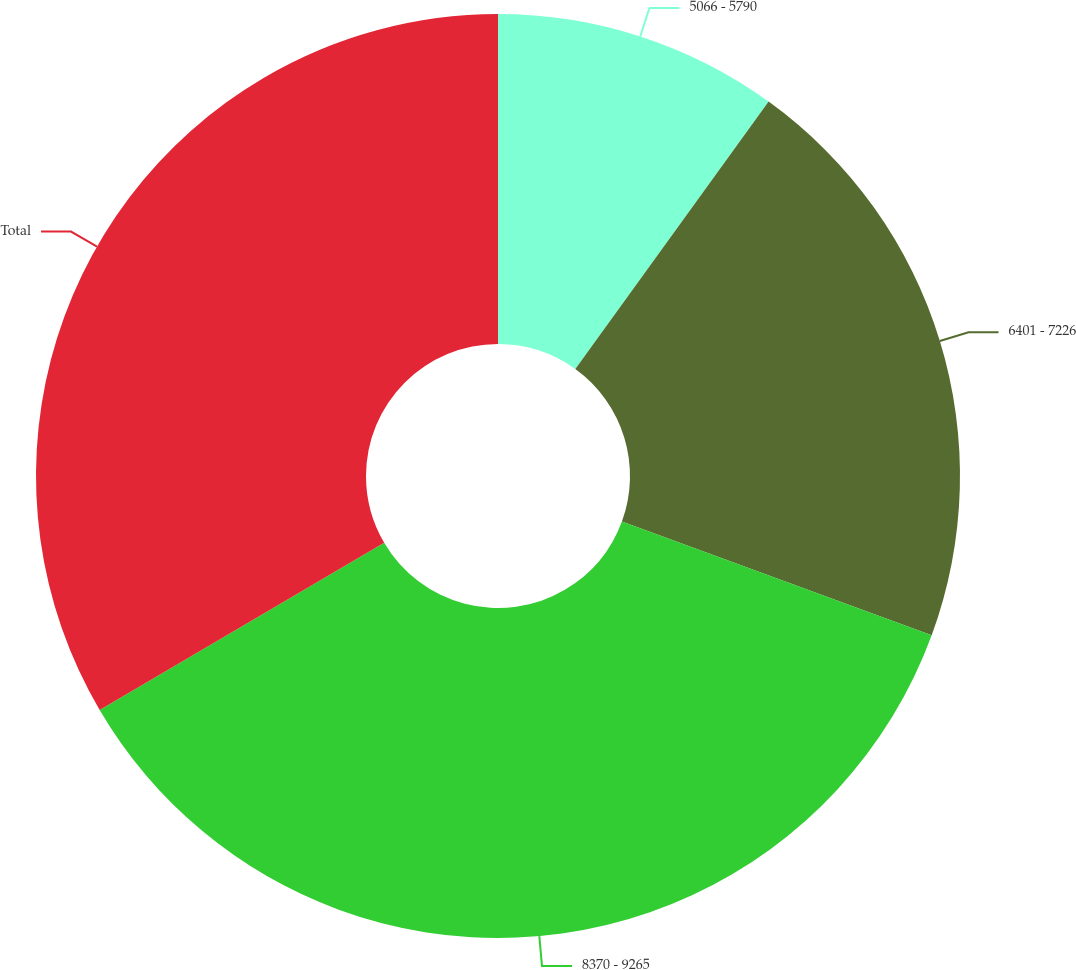Convert chart to OTSL. <chart><loc_0><loc_0><loc_500><loc_500><pie_chart><fcel>5066 - 5790<fcel>6401 - 7226<fcel>8370 - 9265<fcel>Total<nl><fcel>9.96%<fcel>20.64%<fcel>35.94%<fcel>33.45%<nl></chart> 